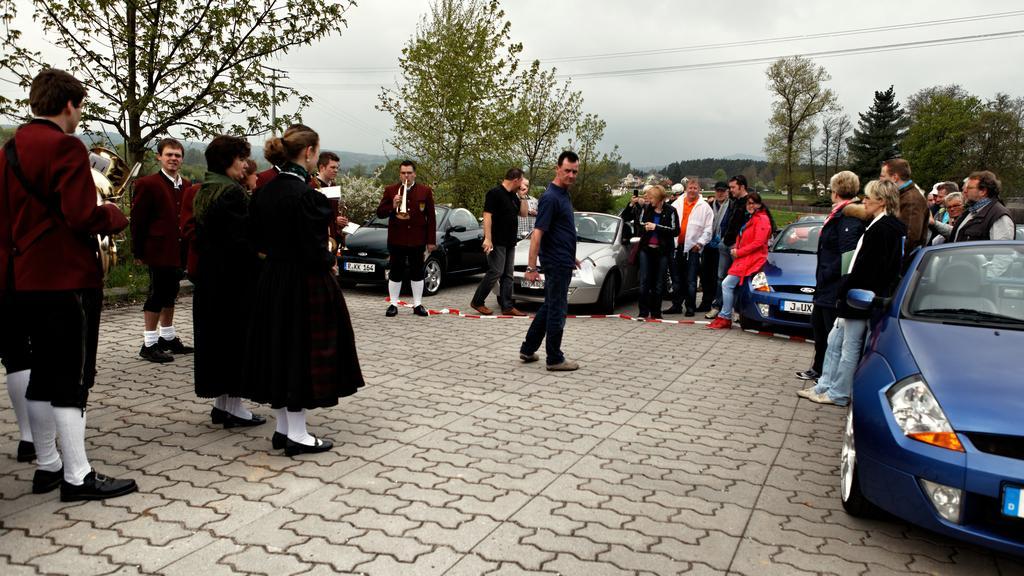How would you summarize this image in a sentence or two? In this image there are many people. There are cars. There are trees and grass. There is an electric pole. There is a sky. 